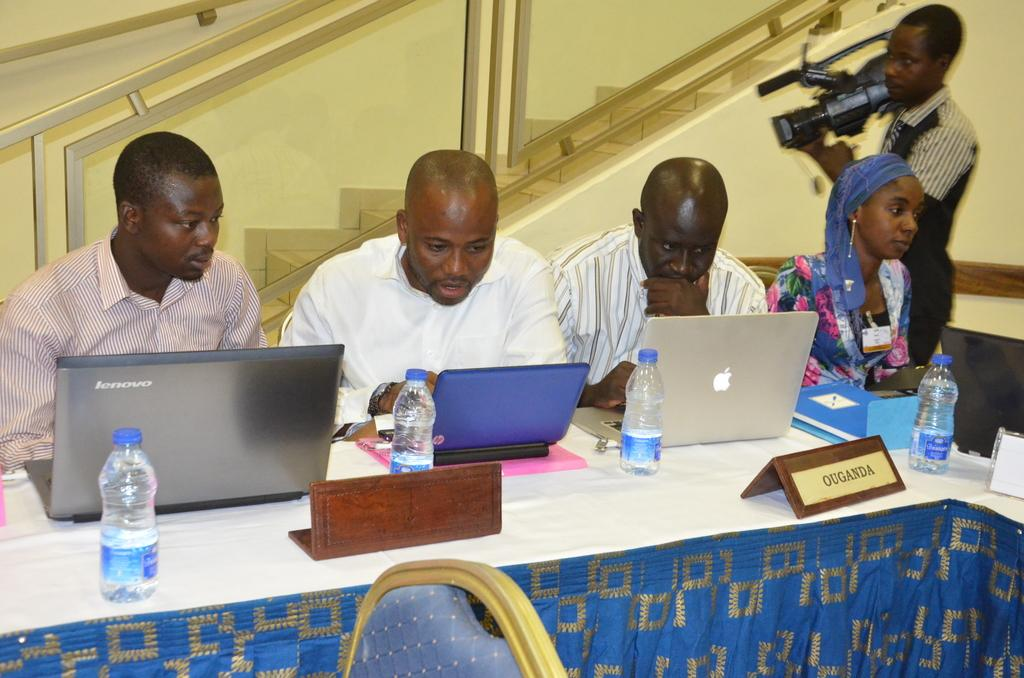<image>
Render a clear and concise summary of the photo. Several men and a woman sit at a blue table with a sign that reads Ouganda 